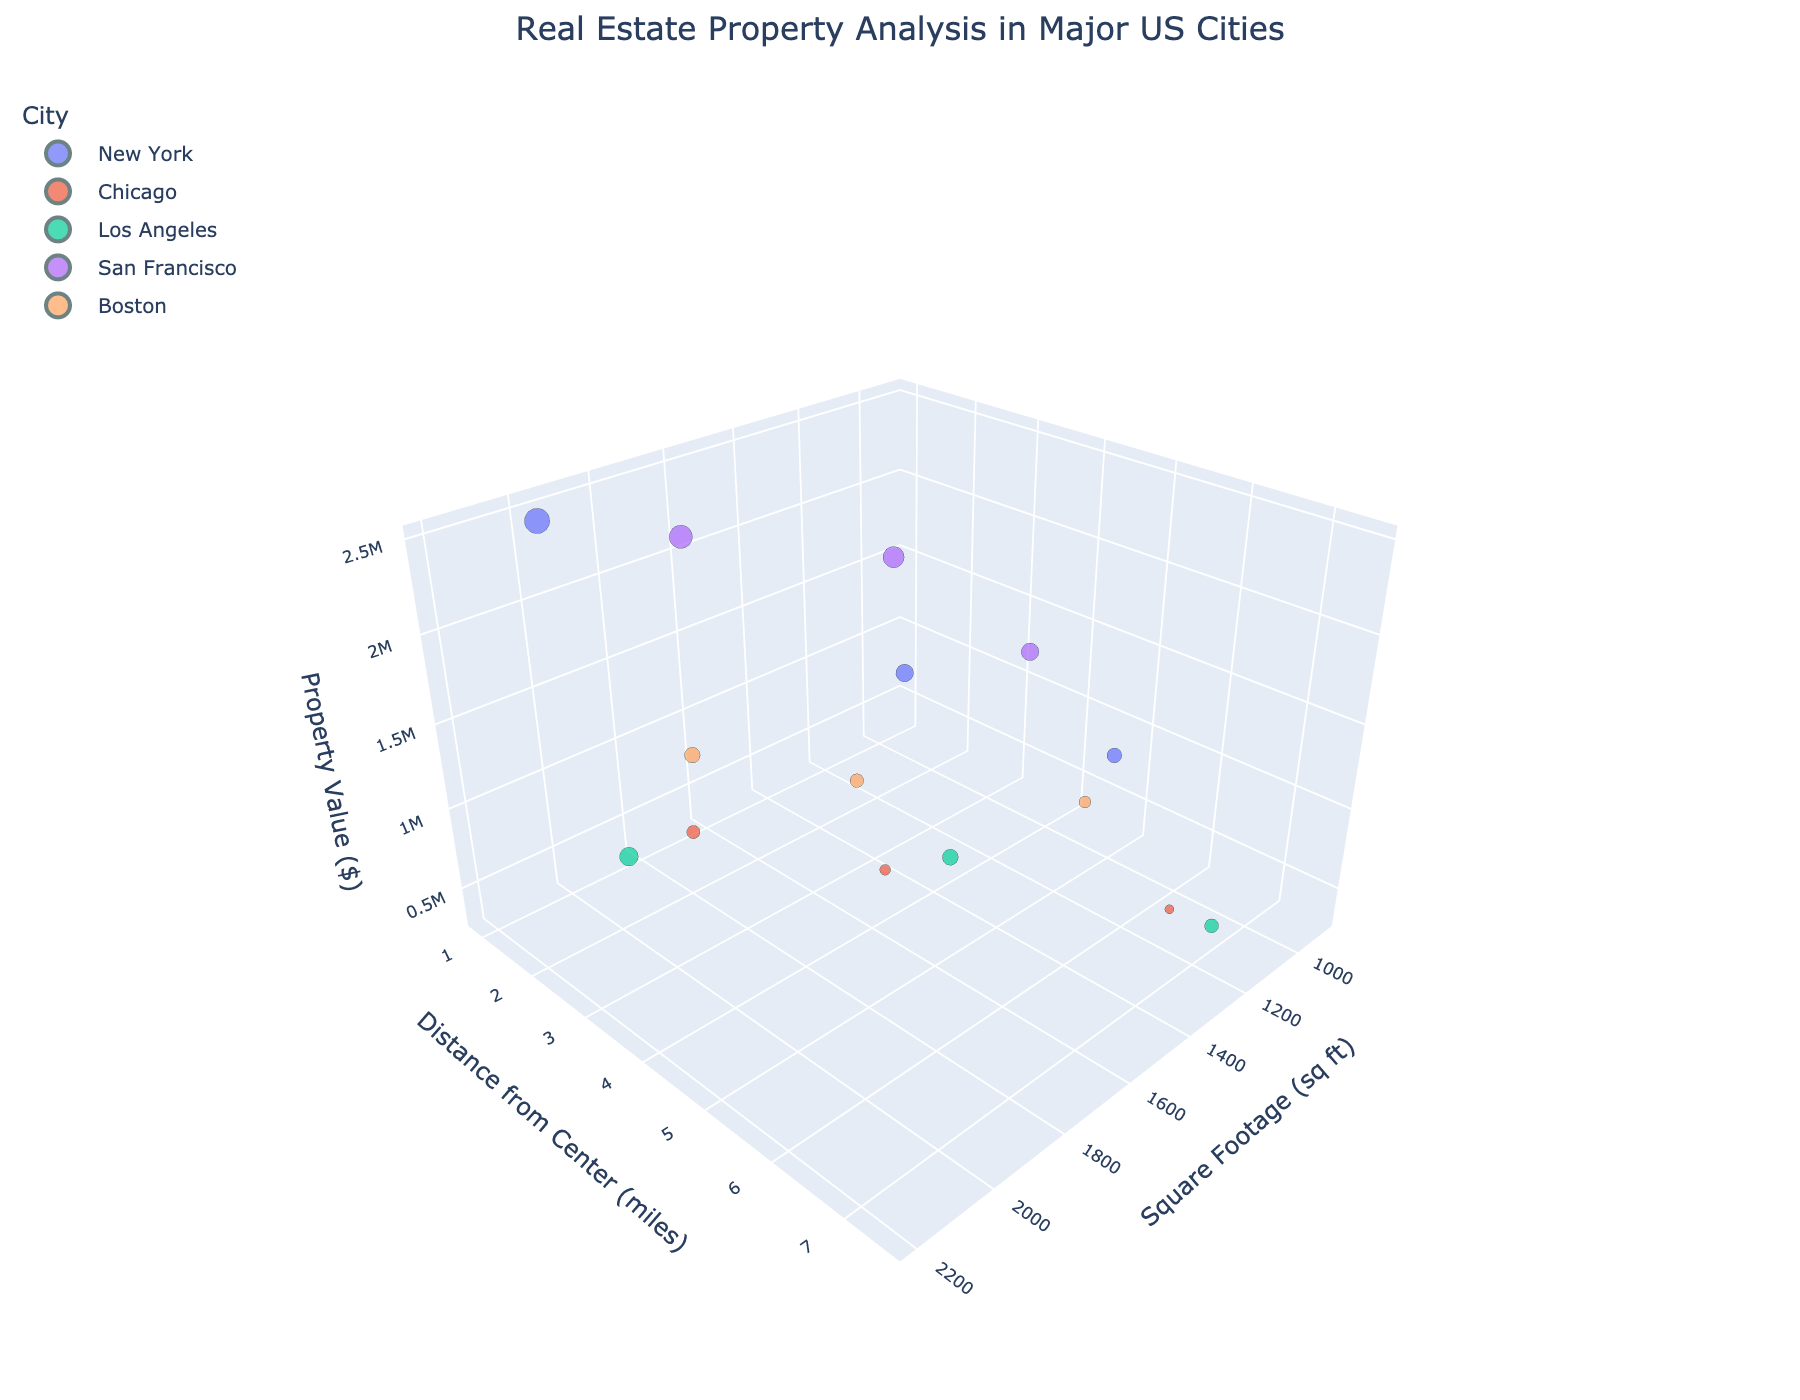What city has the highest property value in the figure? Look for the data point with the highest position along the Property Value axis in the figure and identify its city based on the color legend.
Answer: San Francisco Which city has the lowest property value? Look for the data point with the lowest position along the Property Value axis in the figure and identify its city based on the color legend.
Answer: Chicago What are the axes labels of the 3D scatter plot? Check the labels provided along the three axes in the figure.
Answer: Square Footage (sq ft), Distance from Center (miles), Property Value ($) Compare the property values of the closest points to the city center in New York and Los Angeles. Which city has a higher property value closer to the city center? Identify the points closest to the y-axis (Distance from Center) for New York and Los Angeles and compare their z-axis (Property Value) positions.
Answer: New York How does property value change in relation to distance from the city center in San Francisco? Observe the trend of property value data points for San Francisco as the distance from the city center (y-axis) increases.
Answer: Decreases Comparing two properties, one with the smallest and one with the largest distance from the Chicago city center, which has the higher property value? Identify the points in Chicago with the smallest and largest distances from the center and compare their property values on the z-axis.
Answer: The one with the smallest distance How does square footage relate to property value in Los Angeles? Examine the distribution of data points for Los Angeles along the x-axis (Square Footage) and the z-axis (Property Value) to identify any trends.
Answer: Larger square footage tends to have higher property value Which city has the widest range of square footage values for its properties? Observe the spread of data points along the x-axis for each city and determine which city covers the largest range.
Answer: Los Angeles What's the median property value in New York? Identify New York's property values, sort them, and find the median: 850000, 1200000, 2500000, so the median is the middle value.
Answer: 1200000 